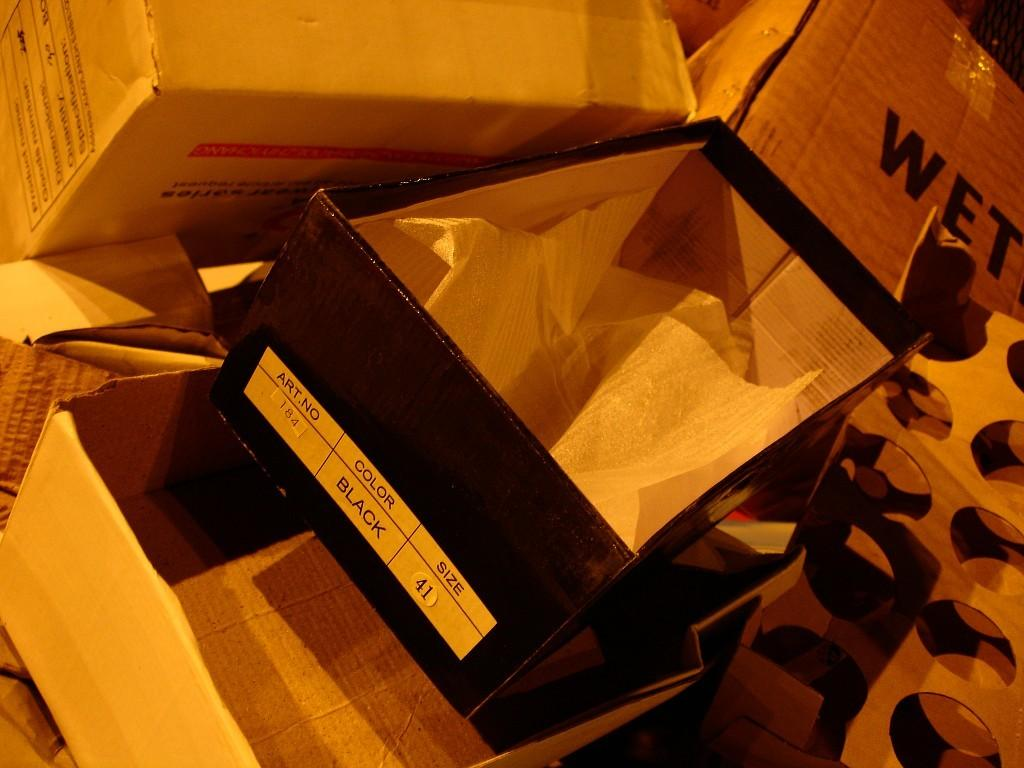<image>
Offer a succinct explanation of the picture presented. Shoe box for a black shoes that was size 41. 